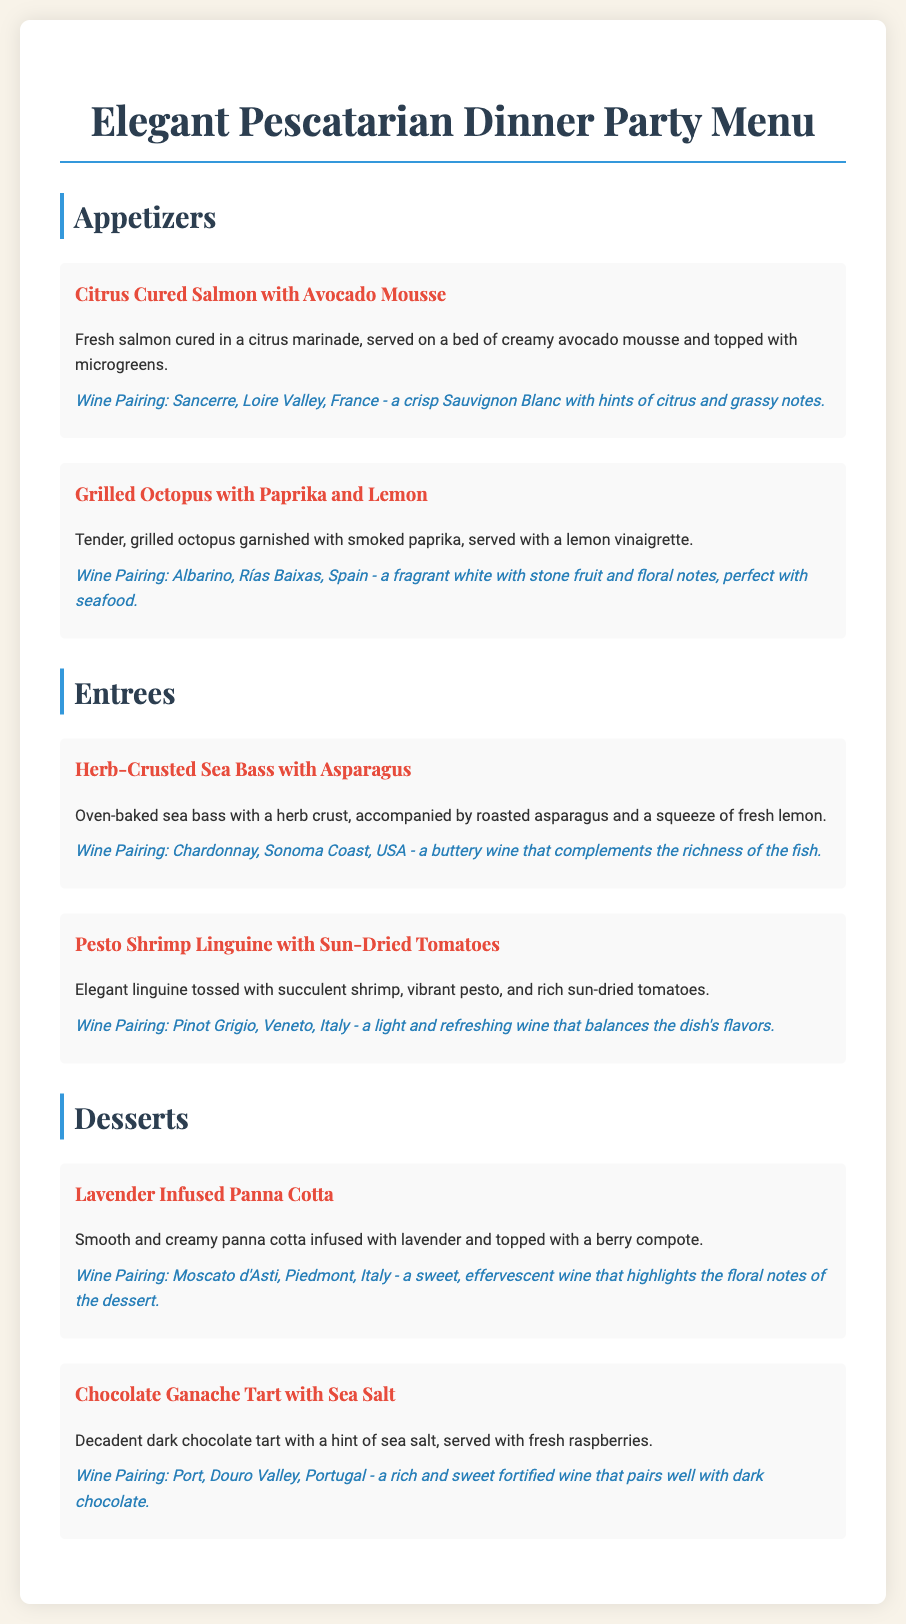what is the first appetizer listed? The first appetizer in the menu is Citrus Cured Salmon with Avocado Mousse.
Answer: Citrus Cured Salmon with Avocado Mousse what wine is paired with Grilled Octopus with Paprika and Lemon? The wine paired with Grilled Octopus is Albarino from Rías Baixas, Spain.
Answer: Albarino, Rías Baixas, Spain how many entrees are listed on the menu? There are two entrees listed on the menu: Herb-Crusted Sea Bass and Pesto Shrimp Linguine.
Answer: 2 what dessert is infused with lavender? The dessert that is infused with lavender is Lavender Infused Panna Cotta.
Answer: Lavender Infused Panna Cotta what is the wine pairing for the Chocolate Ganache Tart? The wine pairing for the Chocolate Ganache Tart is Port from Douro Valley, Portugal.
Answer: Port, Douro Valley, Portugal which seafood dish includes sun-dried tomatoes? The seafood dish that includes sun-dried tomatoes is Pesto Shrimp Linguine.
Answer: Pesto Shrimp Linguine what flavor notes does the Sancerre have? The Sancerre has hints of citrus and grassy notes.
Answer: Hints of citrus and grassy notes what cooking method is used for the sea bass? The sea bass is oven-baked according to the menu.
Answer: Oven-baked 